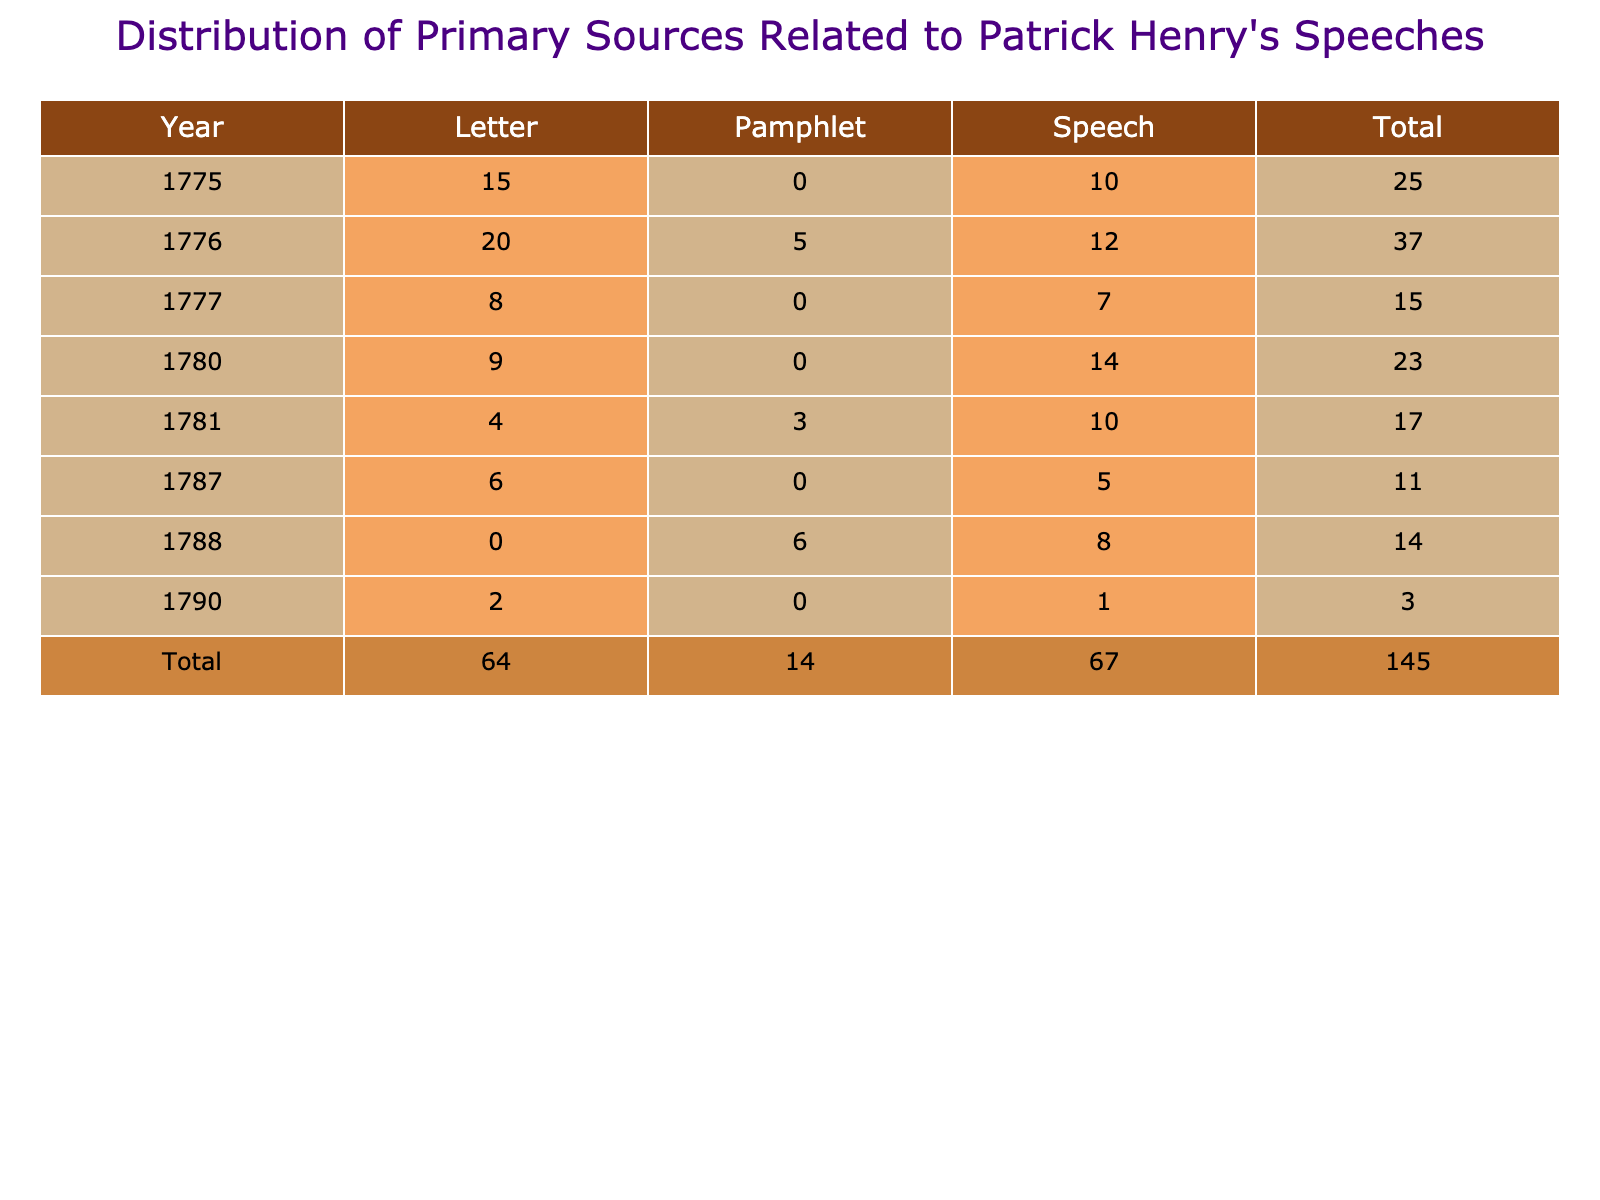What is the total number of speeches recorded in 1776? In 1776, there are two entries under the "Speech" source type: one with a count of 12 and another that consists of the speeches. To find the total, you just refer to the count directly listed as 12.
Answer: 12 What was the combined number of letters and speeches in 1781? For the year 1781, the count for letters is 4, and the count for speeches is 10. Adding these counts together gives 4 + 10 = 14.
Answer: 14 Is there any year where the number of letters exceeds the number of speeches? In 1780, there are 9 letters and 14 speeches. In 1776, there are 20 letters and 12 speeches. Therefore, in 1776, the letters exceed the speeches.
Answer: Yes What year had the highest total of primary sources? To find the highest total, sum the counts for each year: 1775 (25 total), 1776 (37 total), 1777 (15 total), 1780 (23 total), 1781 (17 total), 1787 (11 total), 1788 (14 total), 1790 (3 total). The year with the highest total is 1776 with 37 sources.
Answer: 1776 What percentage of the total sources from 1775 are letters? In 1775, there were a total of 25 sources (15 letters + 10 speeches). The percentage of letters is calculated as (15/25) * 100 = 60%.
Answer: 60% What is the average number of pamphlets per year for the years included in the table? The years noted in the table that have pamphlets are 1776 (5), 1781 (3), 1788 (6), resulting in a total of 14 pamphlets over 3 years. To find the average, divide 14 by 3, which gives approximately 4.67.
Answer: 4.67 In which year were the least number of letters recorded? The year with the least number of letters is 1790, which has a count of 2 letters.
Answer: 1790 How many more speeches than letters were recorded in 1777? In 1777, there are 7 speeches and 8 letters. To find the difference, subtract letters from speeches: 7 - 8 = -1, which means there is 1 more letter than speeches.
Answer: 1 